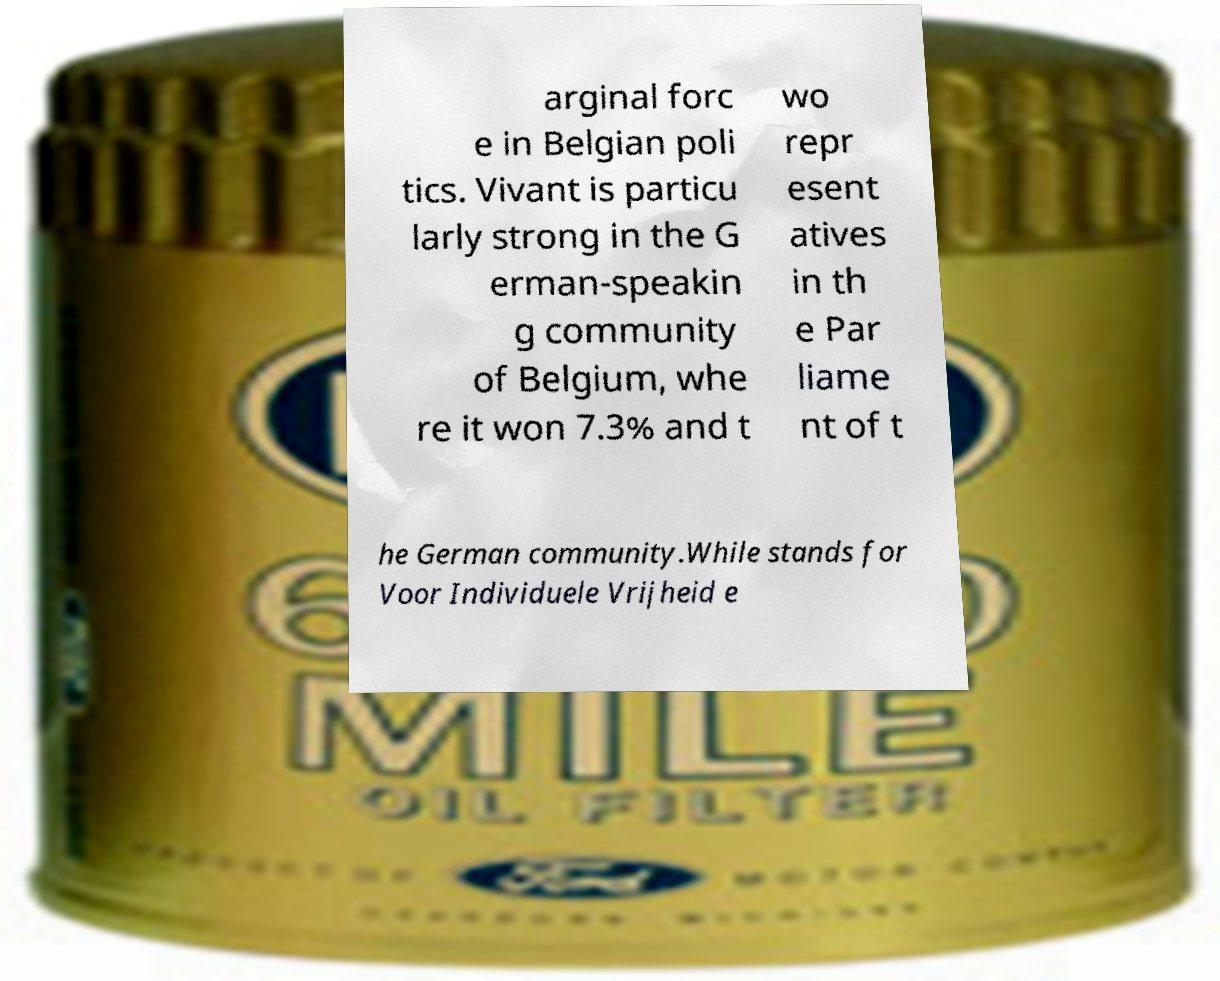Can you read and provide the text displayed in the image?This photo seems to have some interesting text. Can you extract and type it out for me? arginal forc e in Belgian poli tics. Vivant is particu larly strong in the G erman-speakin g community of Belgium, whe re it won 7.3% and t wo repr esent atives in th e Par liame nt of t he German community.While stands for Voor Individuele Vrijheid e 